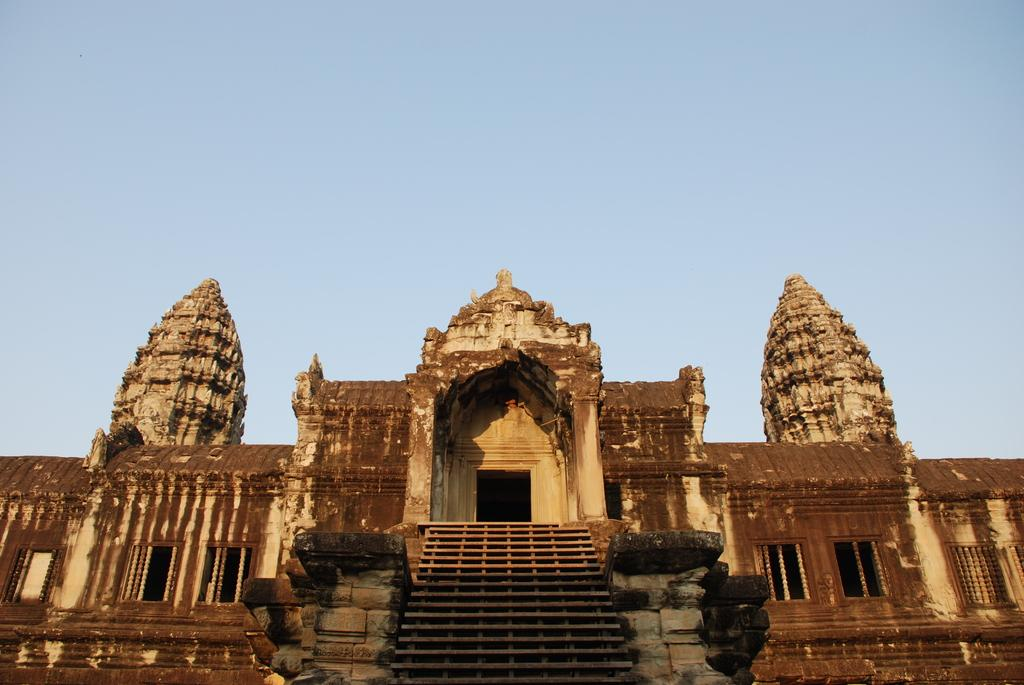Where was the picture taken? The picture was clicked outside. What is the main subject in the center of the image? There is a building in the center of the image. What architectural feature can be seen in the image? There is a stairway visible in the image. What can be seen in the background of the image? The sky is visible in the background of the image. How many carpenters are visible in the image? There are no carpenters present in the image. What type of birds can be seen flying in the image? There are no birds visible in the image. 